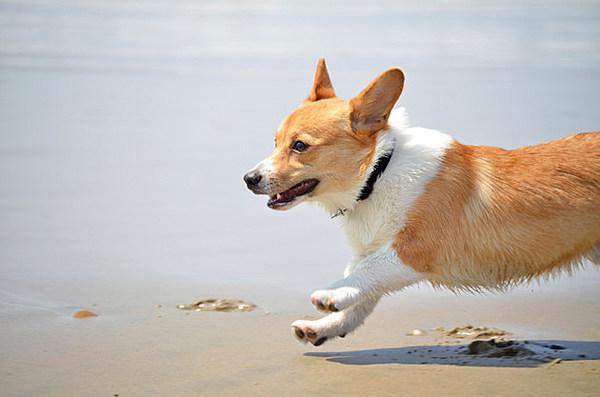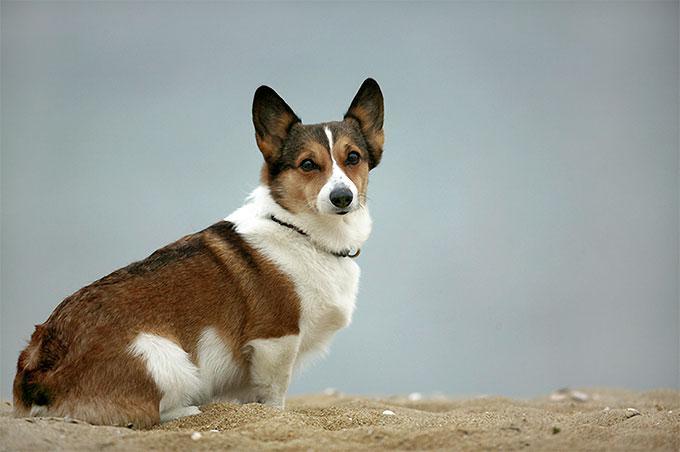The first image is the image on the left, the second image is the image on the right. Evaluate the accuracy of this statement regarding the images: "One of the images shows a corgi sitting on the ground outside with its entire body visible.". Is it true? Answer yes or no. Yes. 